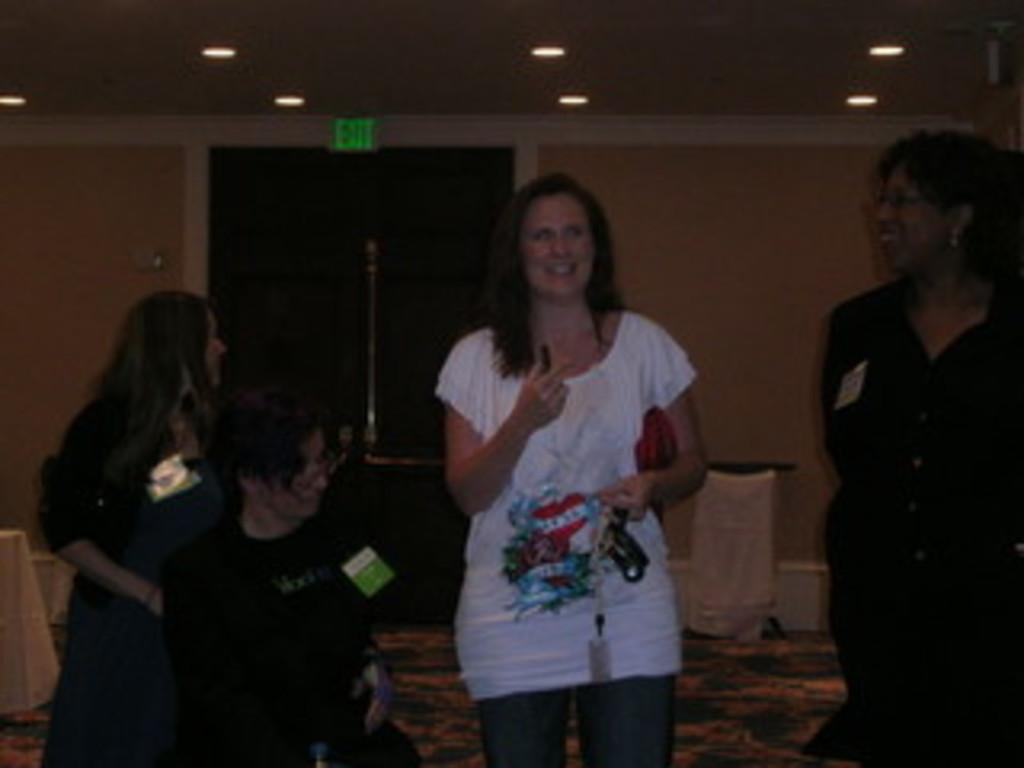How many people are present in the image? There are people in the image, but the exact number is not specified. What are some people wearing in the image? Some people are wearing cards in the image. What is one person doing with an object in the image? One person is holding an object in the image. What can be seen in the background of the image? In the background of the image, there are lights, a board, a wall, and stands. What type of attempt is being made by the people in the image? There is no indication in the image that the people are attempting anything specific. What territory is being claimed by the people in the image? There is no mention of territory or any claim being made in the image. 